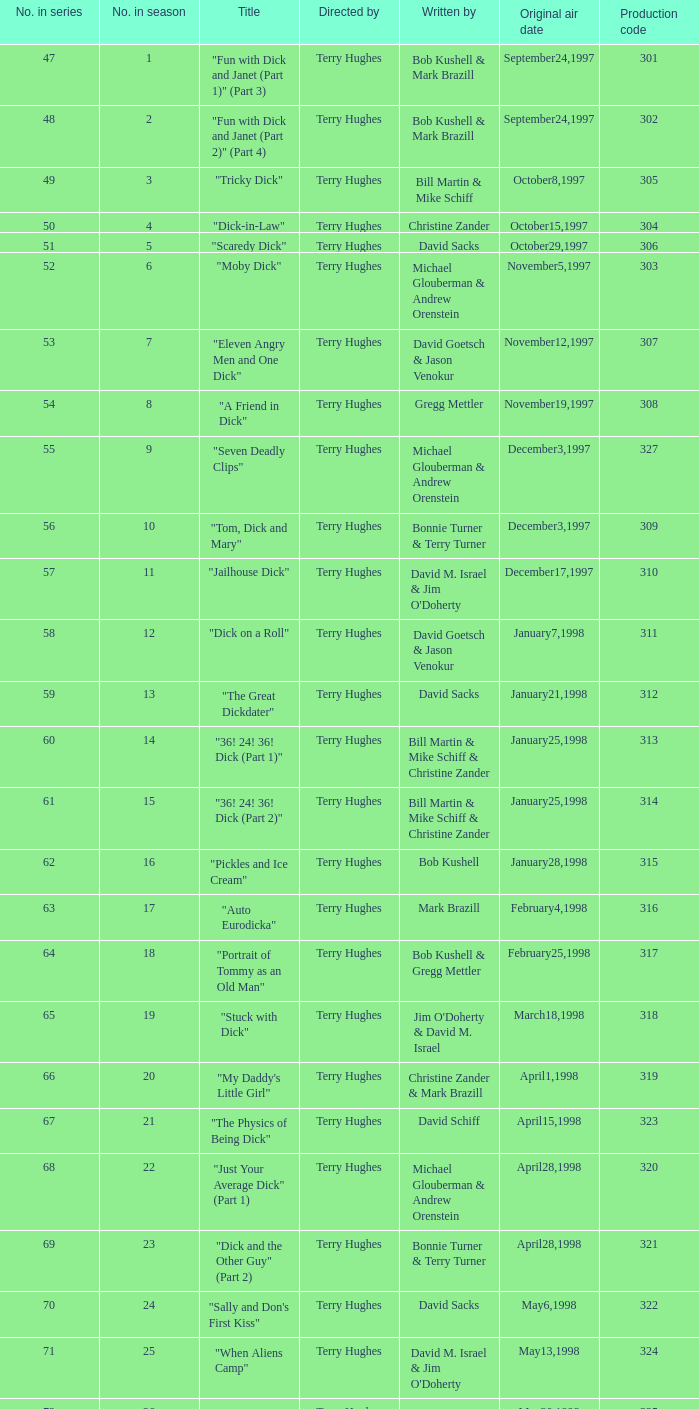Who were the writers of the episode titled "Tricky Dick"? Bill Martin & Mike Schiff. 